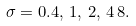<formula> <loc_0><loc_0><loc_500><loc_500>\sigma = 0 . 4 , \, 1 , \, 2 , \, 4 \, 8 .</formula> 